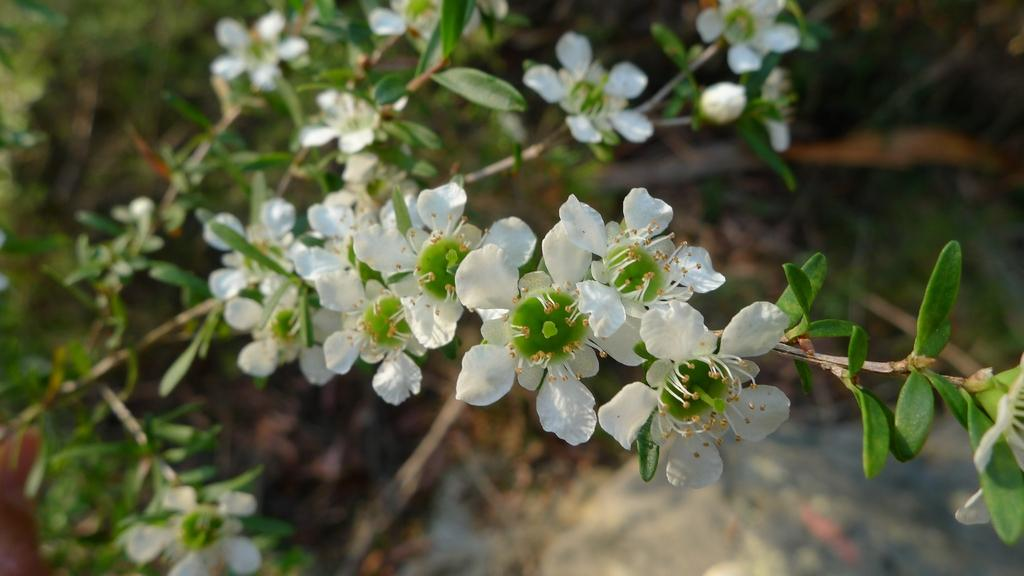What type of flowers are on the plant in the image? There are white flowers on the plant in the image. Can you describe the background of the image? The background of the image is blurred. What type of breakfast is the fireman eating in the image? There is no fireman or breakfast present in the image; it only features white flowers on a plant with a blurred background. 